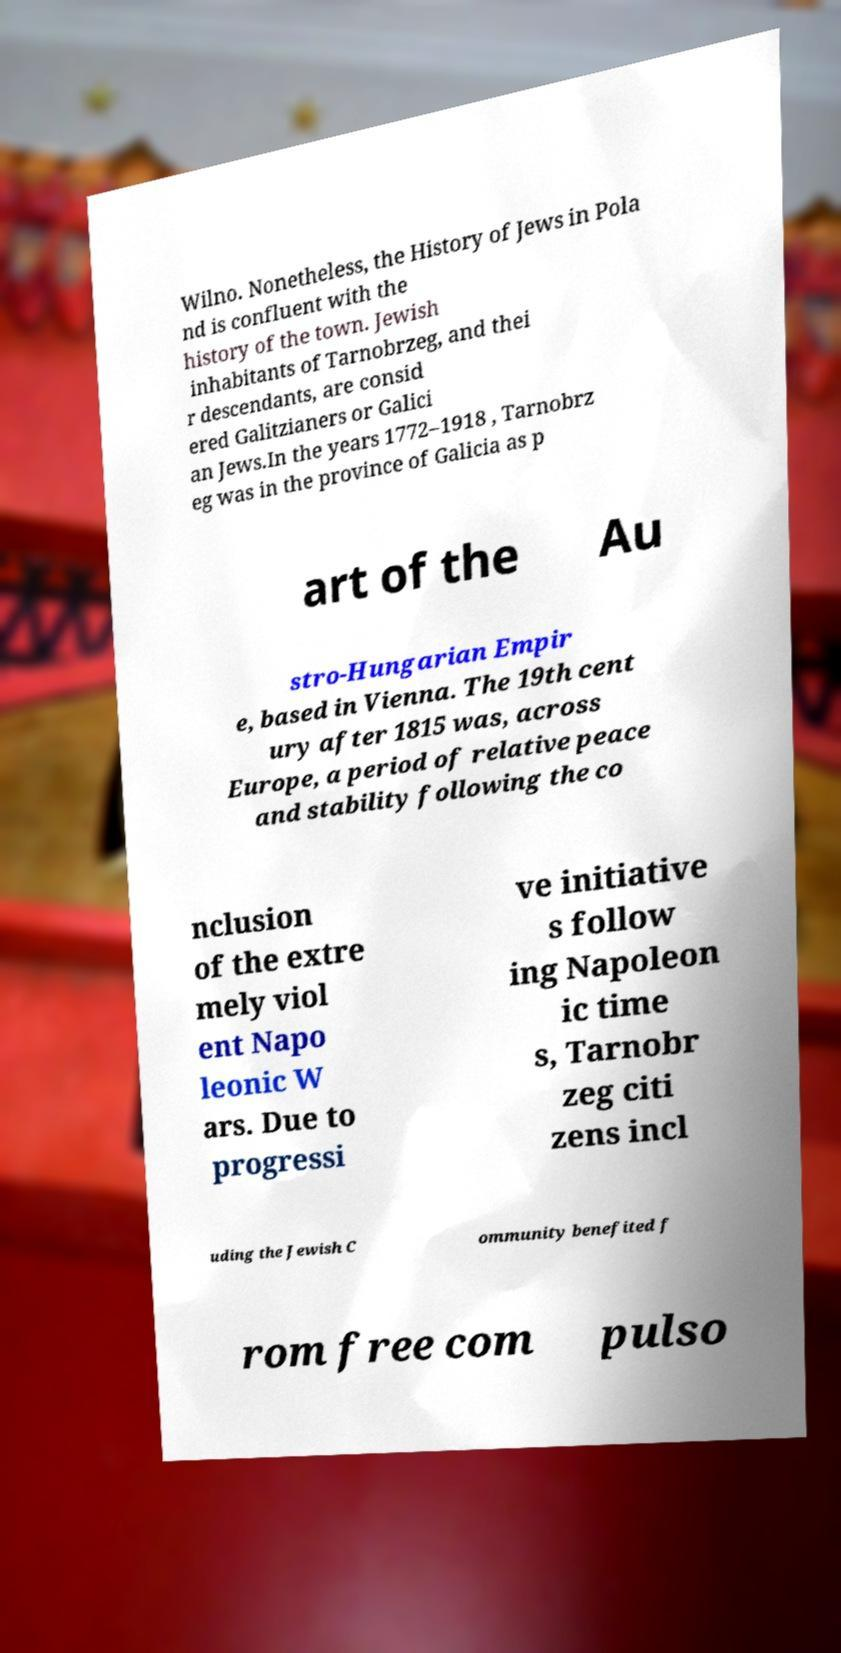Can you read and provide the text displayed in the image?This photo seems to have some interesting text. Can you extract and type it out for me? Wilno. Nonetheless, the History of Jews in Pola nd is confluent with the history of the town. Jewish inhabitants of Tarnobrzeg, and thei r descendants, are consid ered Galitzianers or Galici an Jews.In the years 1772–1918 , Tarnobrz eg was in the province of Galicia as p art of the Au stro-Hungarian Empir e, based in Vienna. The 19th cent ury after 1815 was, across Europe, a period of relative peace and stability following the co nclusion of the extre mely viol ent Napo leonic W ars. Due to progressi ve initiative s follow ing Napoleon ic time s, Tarnobr zeg citi zens incl uding the Jewish C ommunity benefited f rom free com pulso 